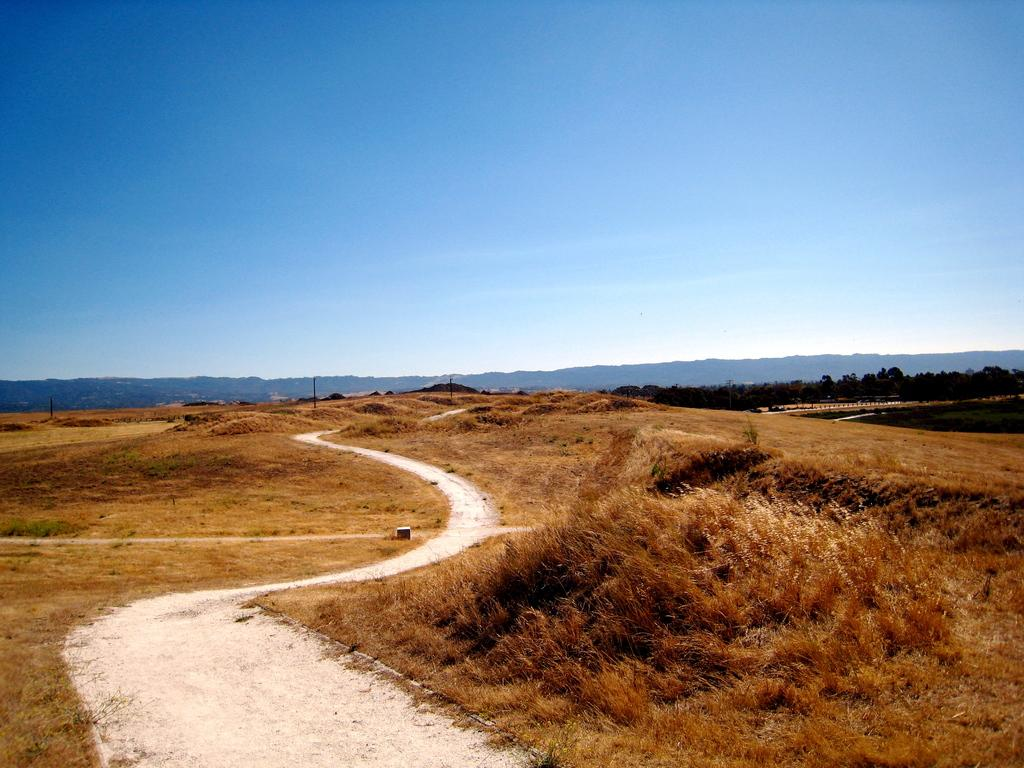What is the main feature of the image? There is a road in the image. What type of vegetation is present on the ground? There is brown grass on the ground in the image. What can be seen in the background of the image? There are trees and poles in the background of the image, as well as the sky. What type of acoustics can be heard from the scarecrow in the image? There is no scarecrow present in the image, so it is not possible to determine the acoustics. 